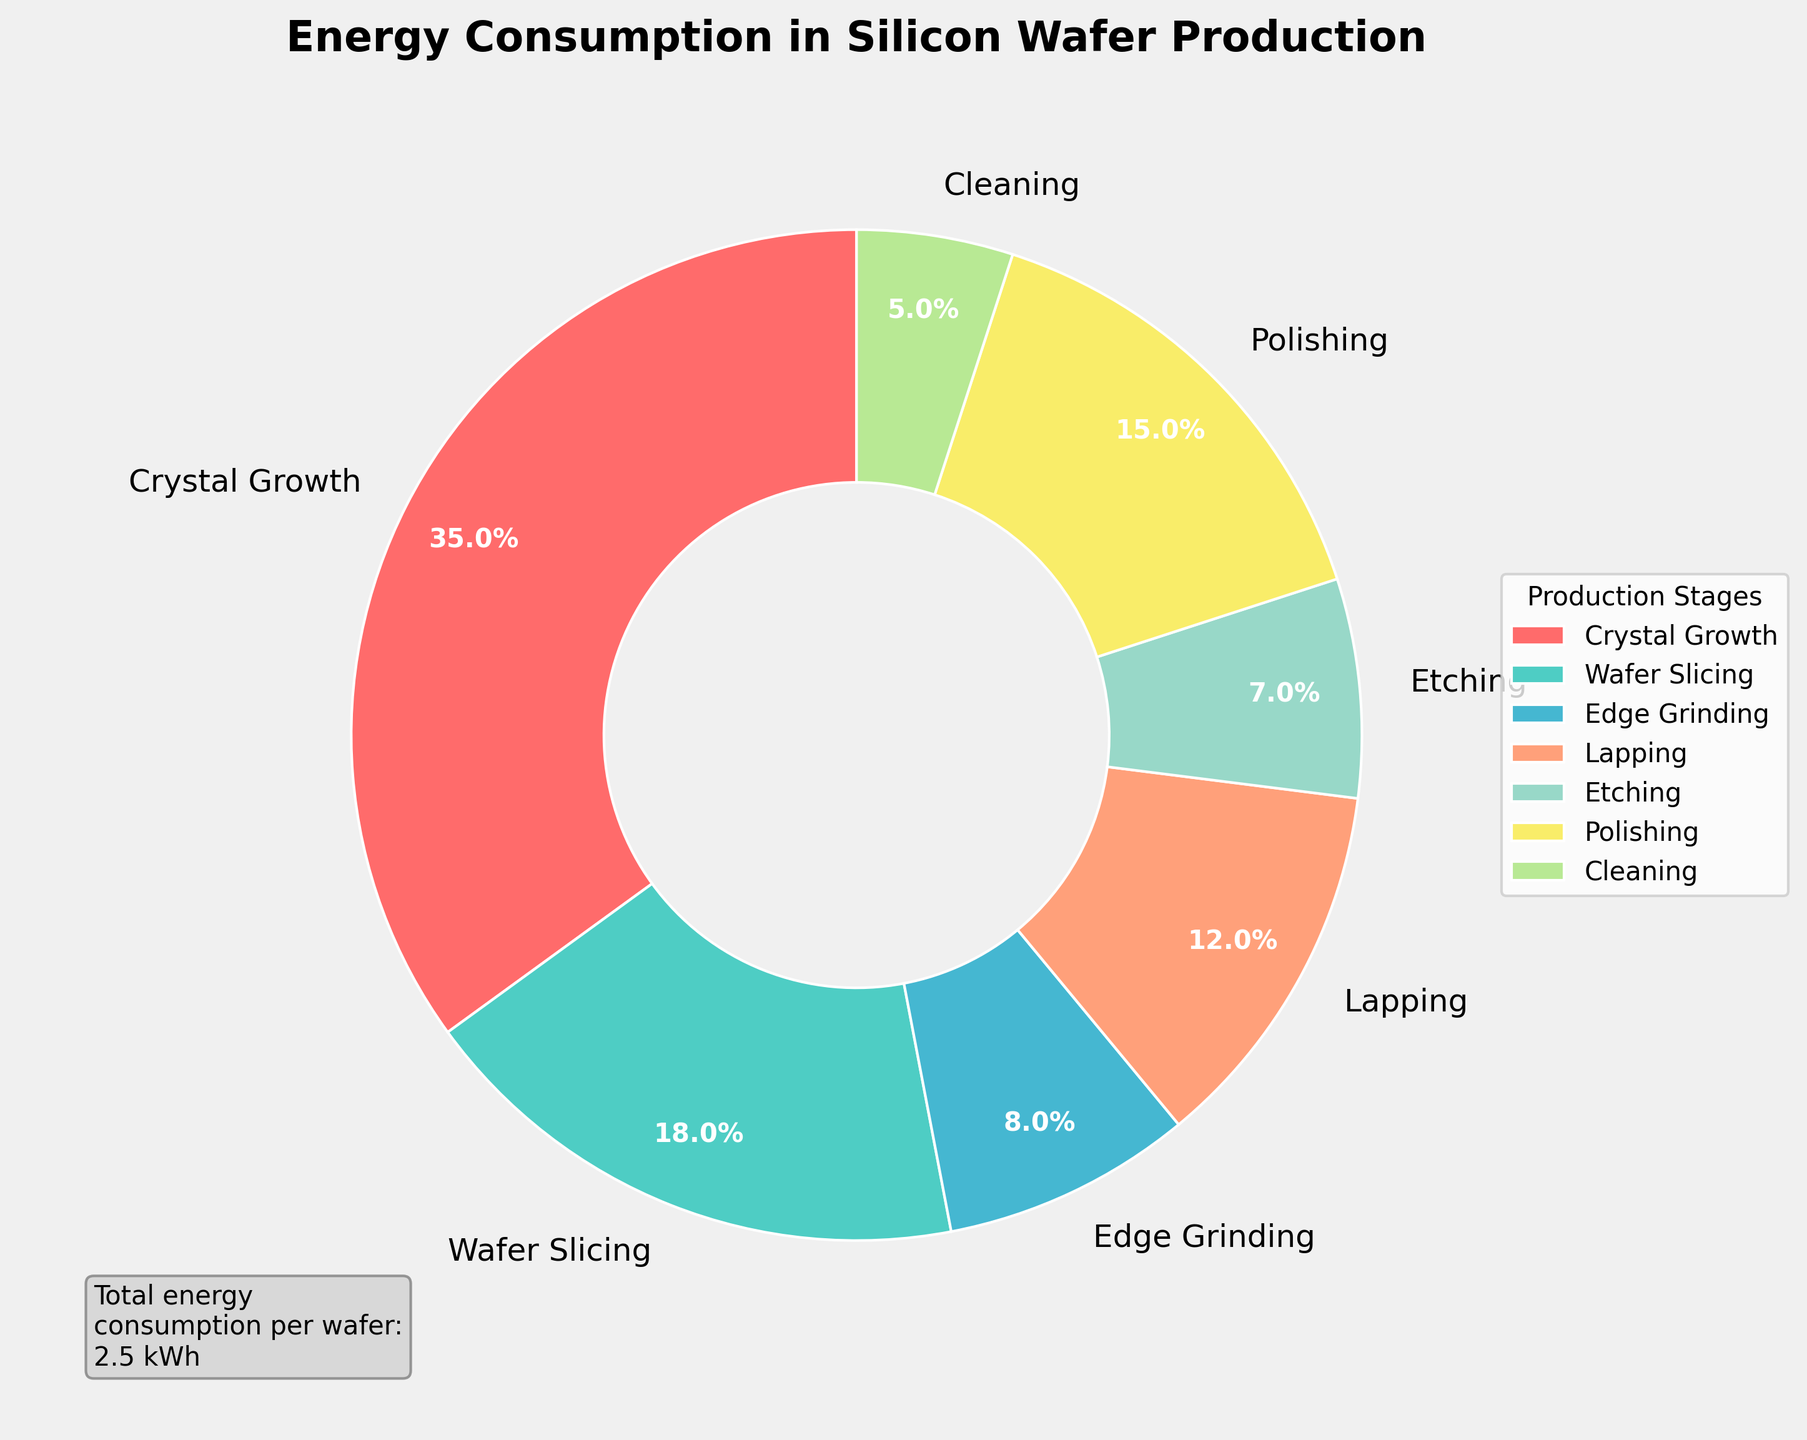Which stage consumes the most energy? The figure shows a pie chart where the 'Crystal Growth' stage has the largest portion, indicated by a percentage of 35%.
Answer: Crystal Growth Which two stages together consume the same energy as the 'Polishing' stage? The 'Polishing' stage consumes 15%. The 'Lapping' stage at 12% and the 'Cleaning' stage at 5% together make 17%, which is closest but slightly more. The 'Wafer Slicing' stage at 18% is the closest single stage to 15%. However, 'Lapping' (12%) and 'Edge Grinding' (8%) are summing to 20%, which exceeds 15%. Thus, the sum of 'Etching' and 'Edge Grinding' (7% + 8%) which reaches 15% exactly combines to match 'Polishing'.
Answer: Etching and Edge Grinding Is the energy consumption for 'Crystal Growth' more than double that of 'Wafer Slicing'? 'Crystal Growth' consumes 35% and 'Wafer Slicing' consumes 18%. Since 35% is more than double 18% (which would be 36%), the visual representation supports this. However, 35% is slightly less so it's close but not double.
Answer: No What fraction of the total energy consumption is less than 10%? The stages with energy consumption less than 10% are: 'Edge Grinding' (8%), 'Etching' (7%), and 'Cleaning' (5%). Adding these gives us: 8% + 7% + 5% = 20%. This represents 3 stages out of 7, so 3/7 = 0.4285 (about 43%).
Answer: 43% By how much does the energy consumption of 'Crystal Growth' exceed that of 'Polishing'? The 'Crystal Growth' stage consumes 35%, and the 'Polishing' stage consumes 15%. The difference is 35% - 15% = 20%.
Answer: 20% Which stages combined have an energy consumption equal to 'Wafer Slicing'? 'Wafer Slicing' consumes 18%. 'Edge Grinding' (8%) plus 'Polishing' (15%) equal to 23%, which is too high. 'Lapping' (12%) and 'Edge Grinding' (8%) combined equals 20%, also too high. 'Etching' (7%) and 'Lapping' (12%) together sums up to 19%, also higher. Thus, 'Etching' (7%) and 'Cleaning' (5%) which combine to 12% is closest except lowest possible below 18%, showing no exact match stages to total 18%.
Answer: No exact match Is the sum of the energy consumption of 'Cleaning' and 'Polishing' higher than that of 'Wafer Slicing'? 'Cleaning' consumes 5% and 'Polishing' consumes 15%. Combined, their energy consumption is 5% + 15% = 20%. 'Wafer Slicing' consumes 18%. Since 20% > 18%, the answer is yes.
Answer: Yes What is the smallest energy-consuming stage, and what percentage does it represent? The pie chart shows that 'Cleaning' has the smallest segment, with an energy consumption of 5%.
Answer: Cleaning, 5% 